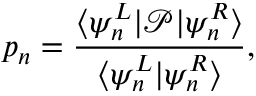Convert formula to latex. <formula><loc_0><loc_0><loc_500><loc_500>p _ { n } = \frac { \langle \psi _ { n } ^ { L } | \mathcal { P } | \psi _ { n } ^ { R } \rangle } { \langle \psi _ { n } ^ { L } | \psi _ { n } ^ { R } \rangle } ,</formula> 